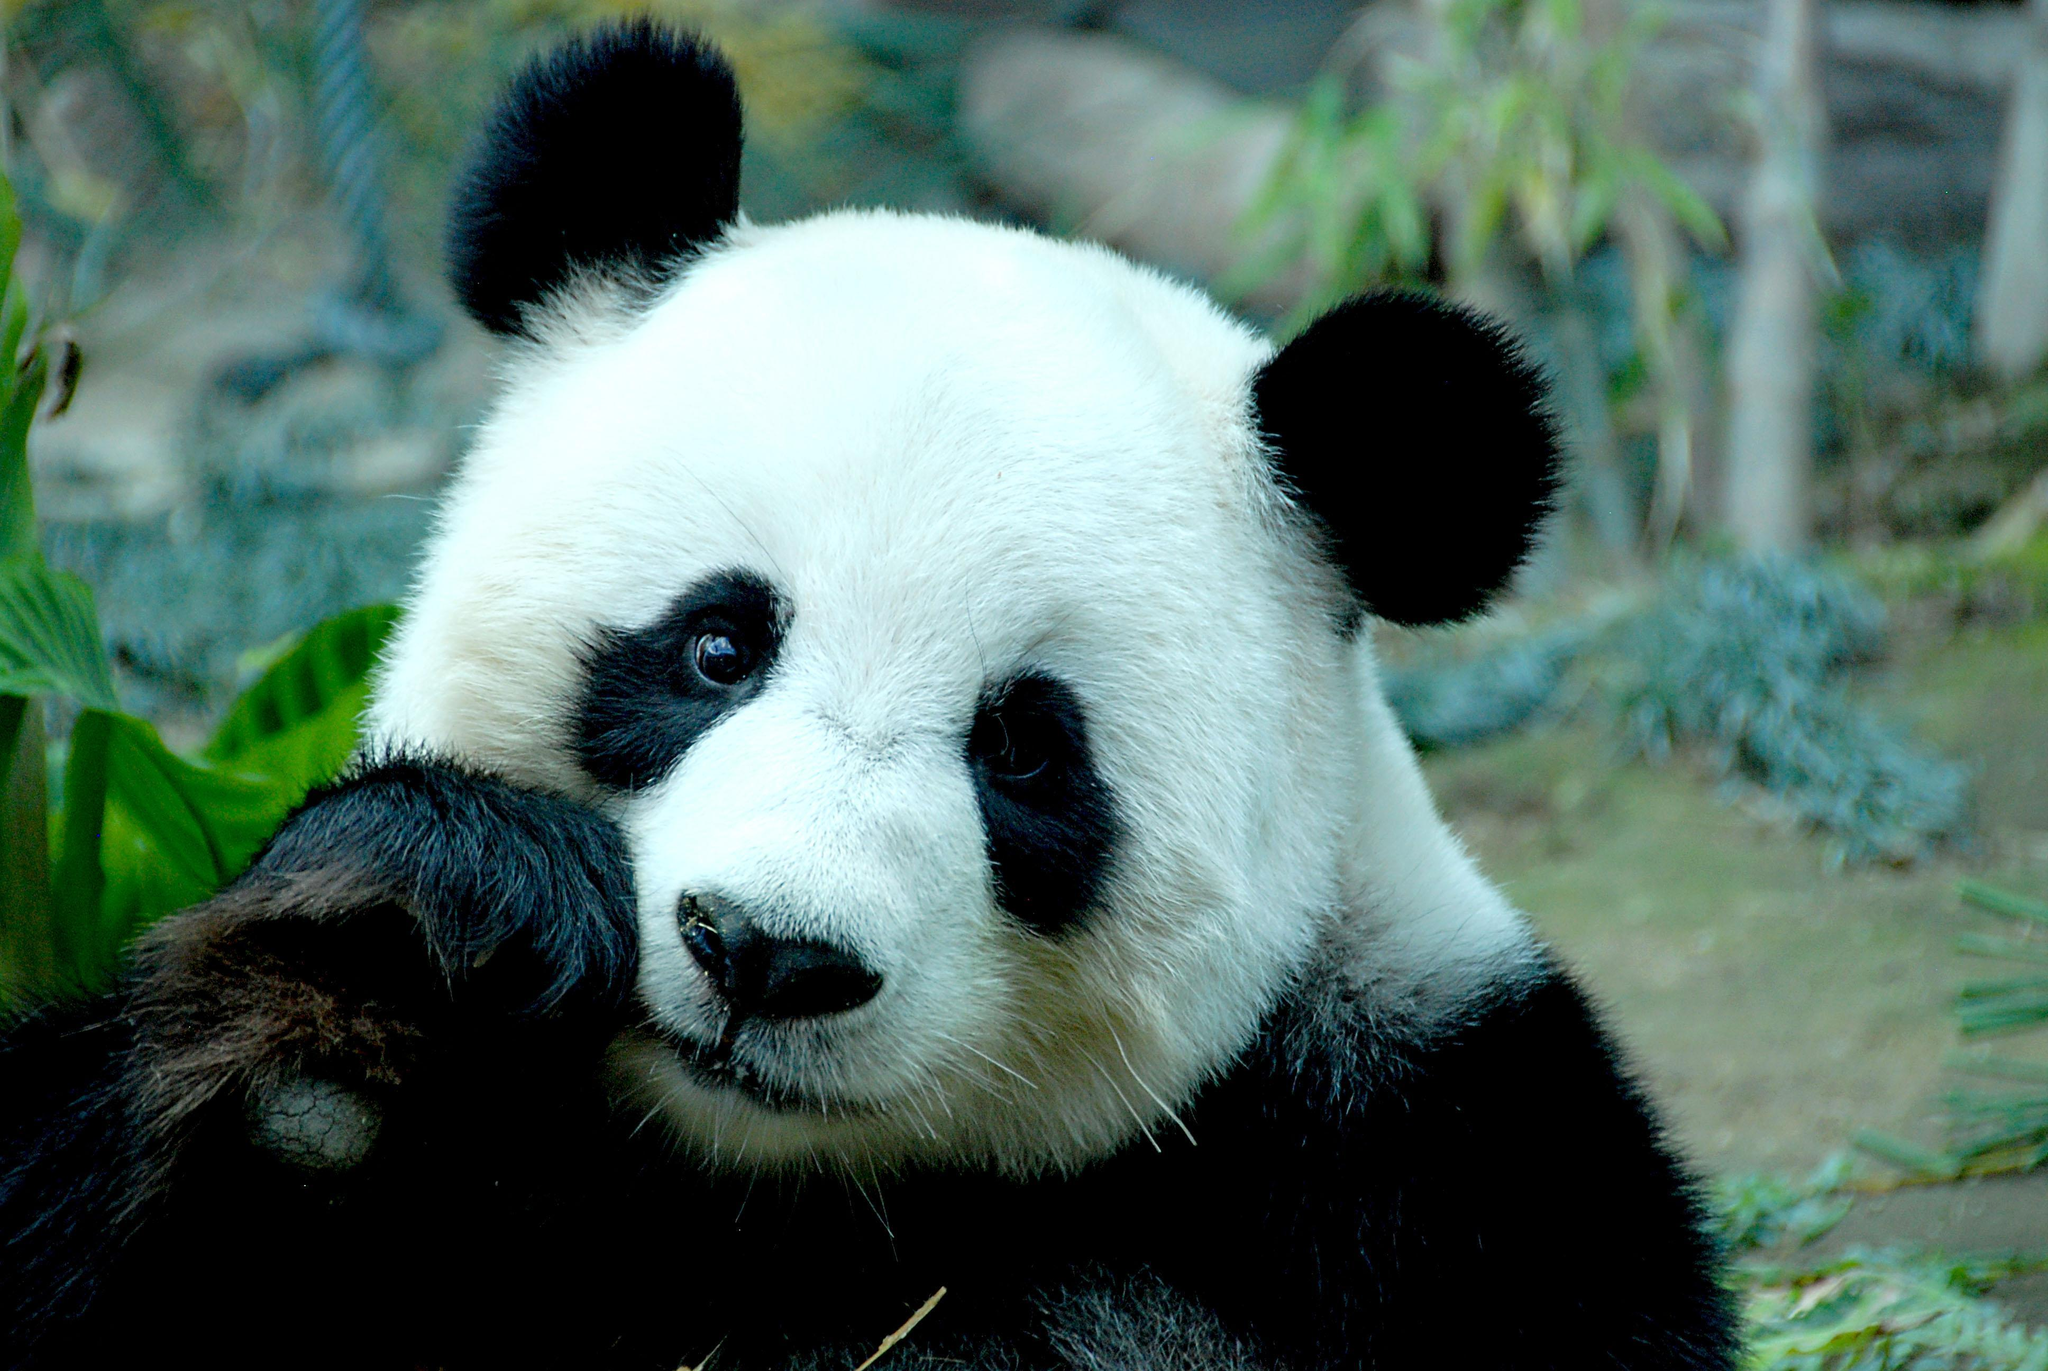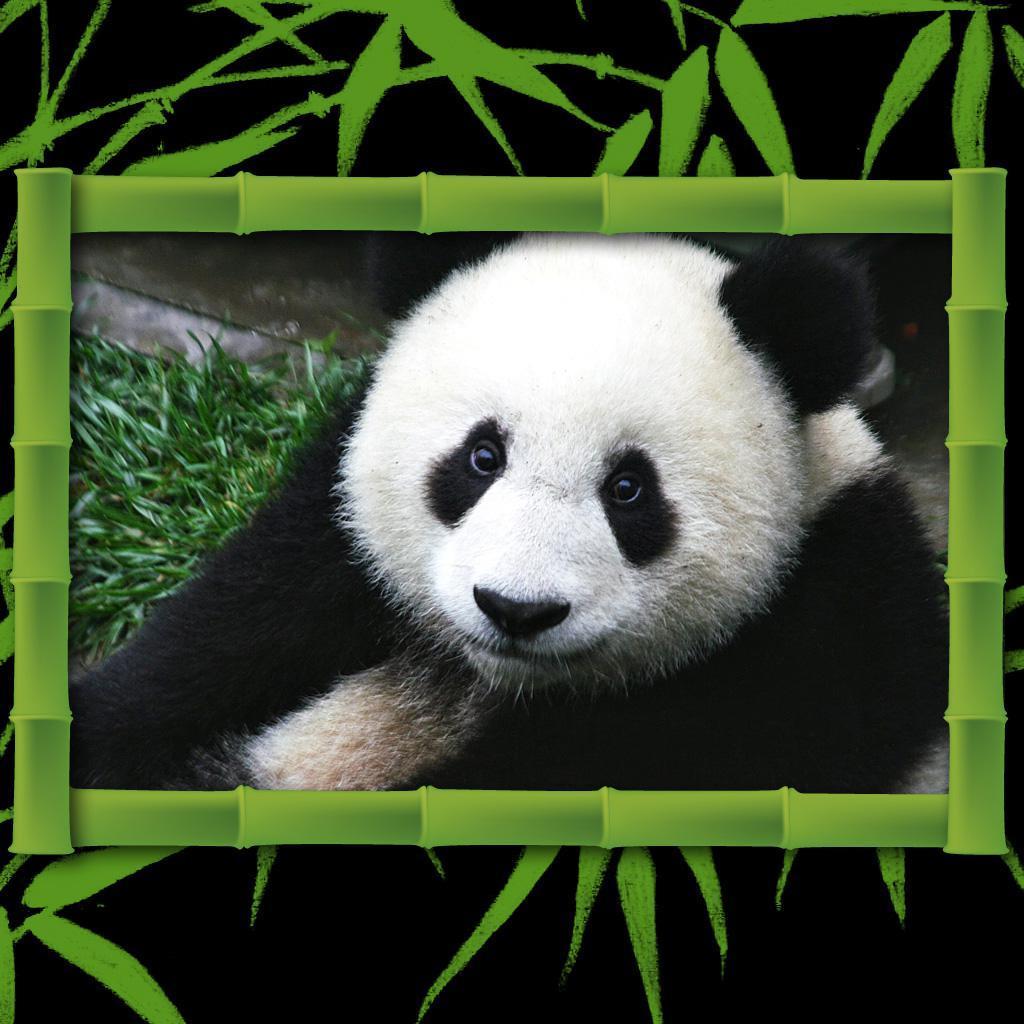The first image is the image on the left, the second image is the image on the right. Examine the images to the left and right. Is the description "At least one panda is playing with a bubble." accurate? Answer yes or no. No. 